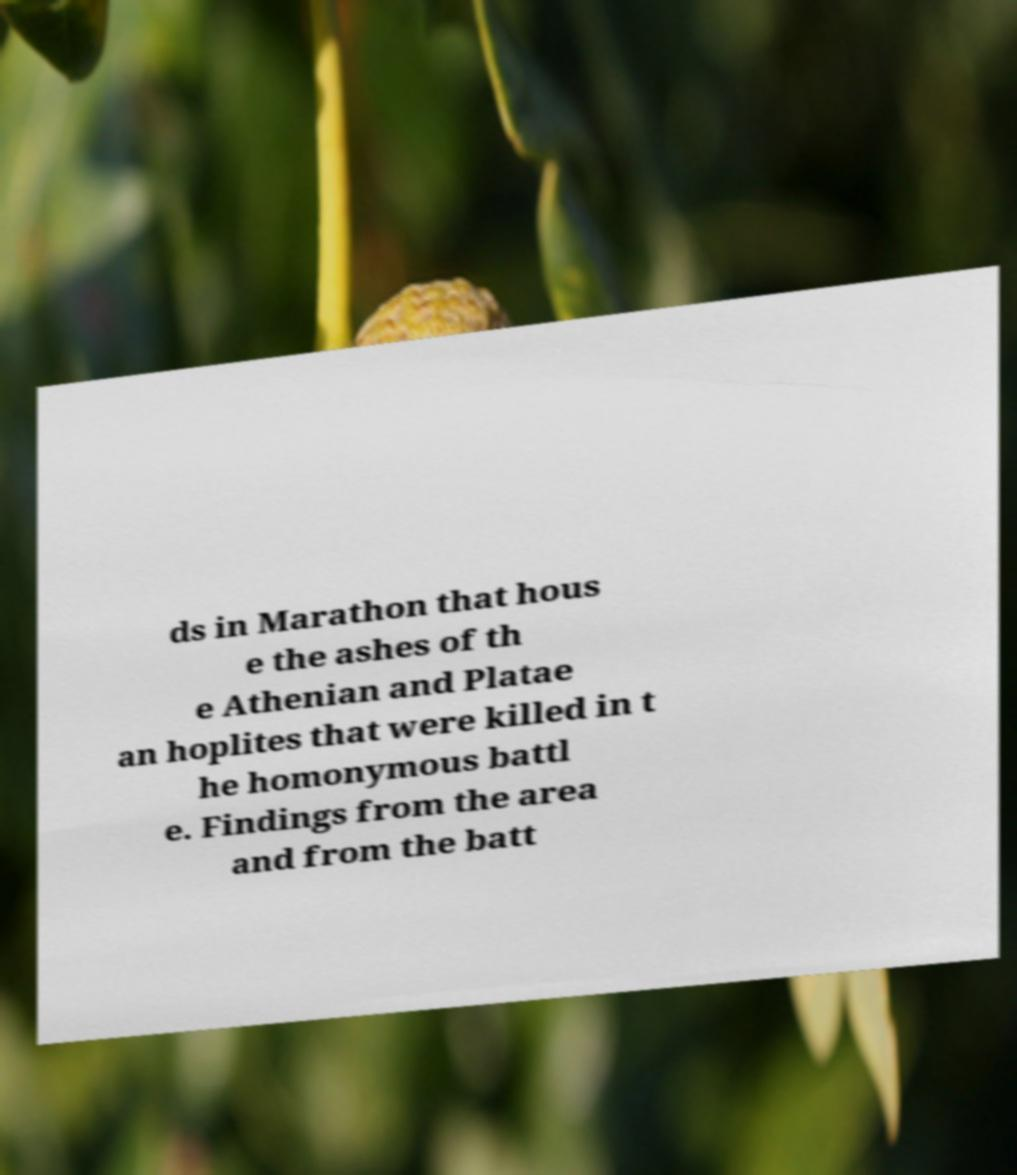Could you assist in decoding the text presented in this image and type it out clearly? ds in Marathon that hous e the ashes of th e Athenian and Platae an hoplites that were killed in t he homonymous battl e. Findings from the area and from the batt 